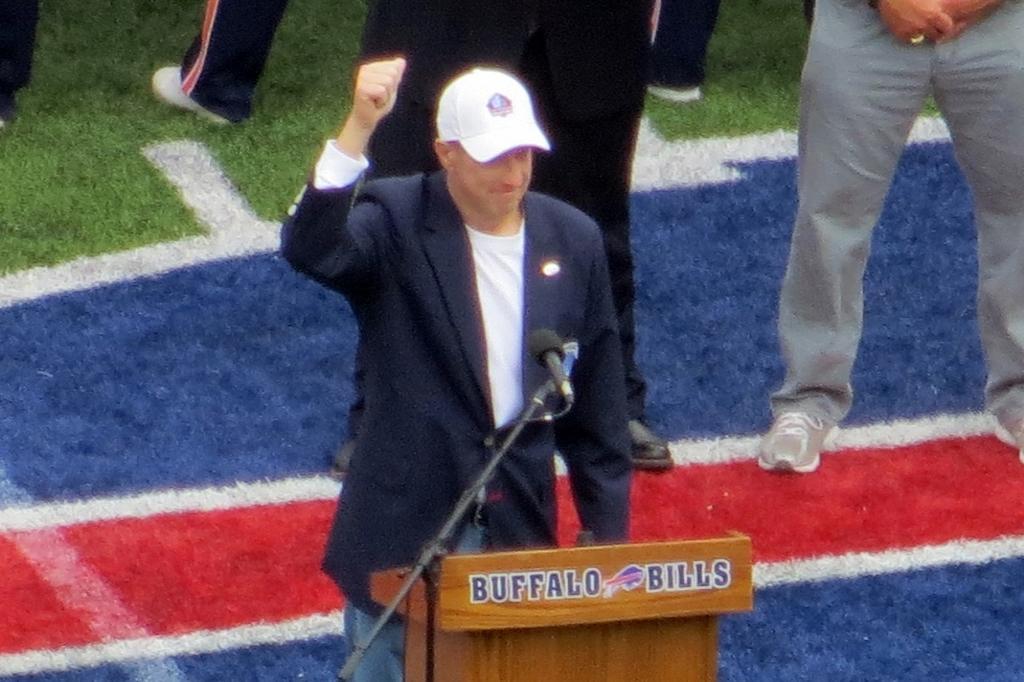Can you describe this image briefly? In this image we can see a group of people standing on the ground. One person is wearing a coat and cap. In the foreground we can see a podium and a microphone placed on a stand. 